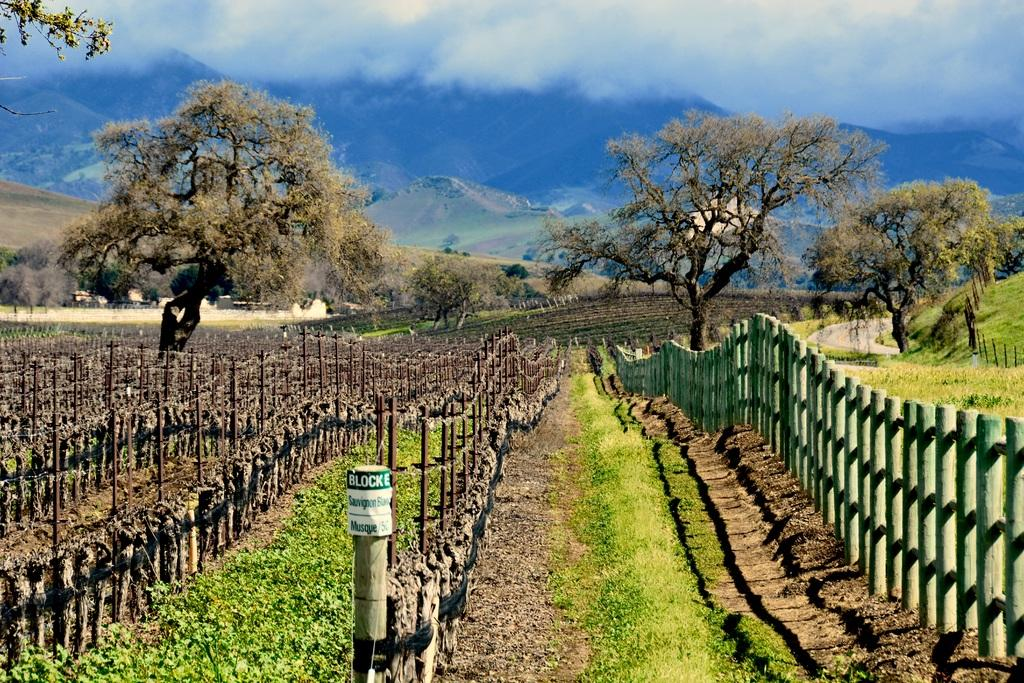What type of landscape is depicted in the image? The image features fields. What structures can be seen in the fields? There are wooden poles in the fields. What is located on the right side of the image? There is fencing on the right side of the image. What can be seen in the background of the image? There are trees, mountains, and the sky visible in the background of the image. How much payment is required to enter the airport in the image? There is no airport present in the image; it features fields, wooden poles, fencing, trees, mountains, and the sky. 